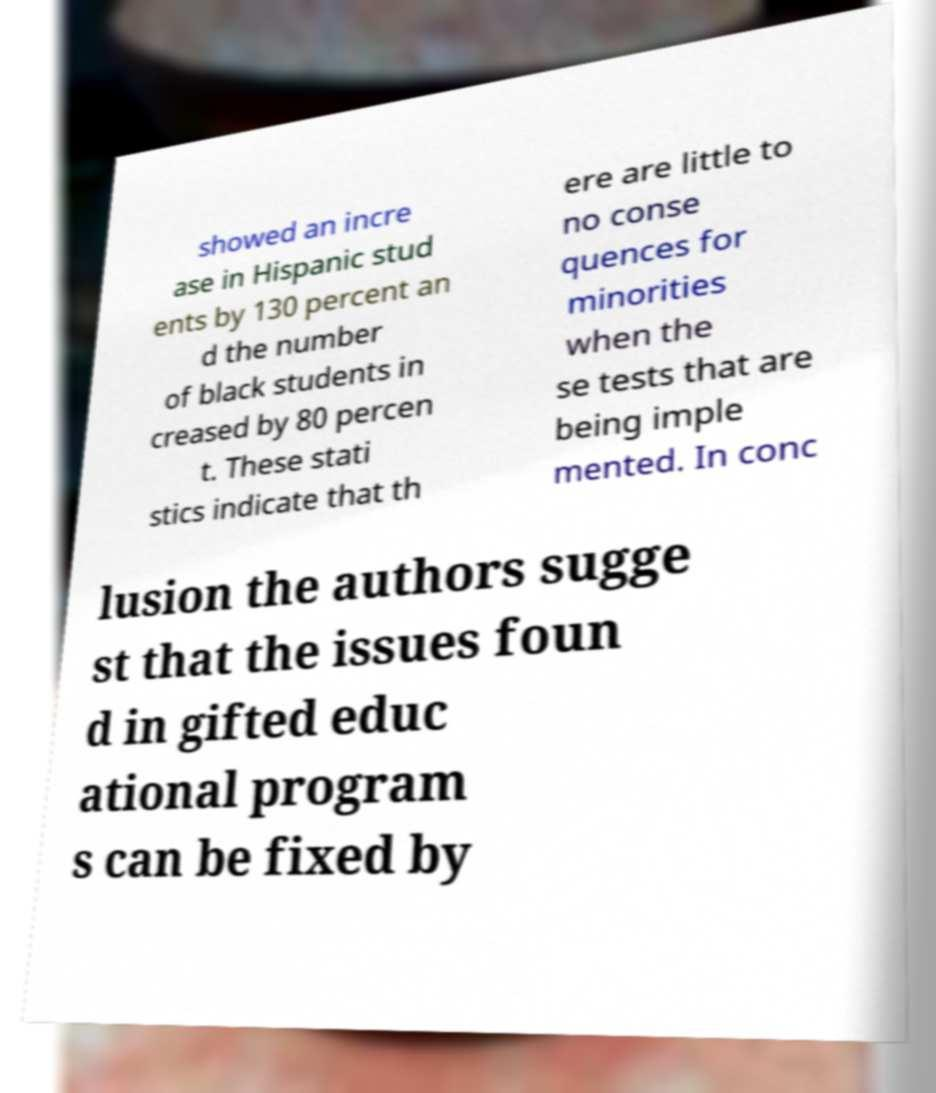Can you accurately transcribe the text from the provided image for me? showed an incre ase in Hispanic stud ents by 130 percent an d the number of black students in creased by 80 percen t. These stati stics indicate that th ere are little to no conse quences for minorities when the se tests that are being imple mented. In conc lusion the authors sugge st that the issues foun d in gifted educ ational program s can be fixed by 